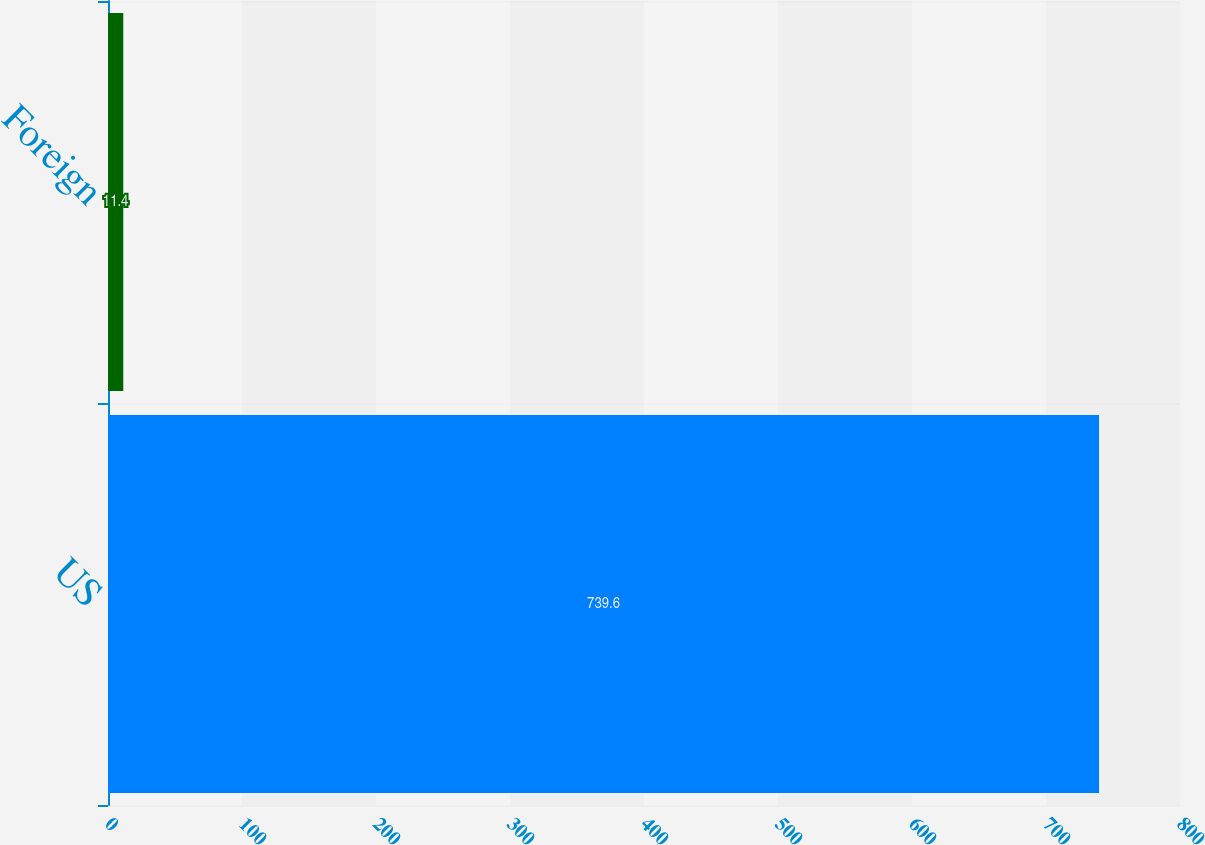Convert chart. <chart><loc_0><loc_0><loc_500><loc_500><bar_chart><fcel>US<fcel>Foreign<nl><fcel>739.6<fcel>11.4<nl></chart> 